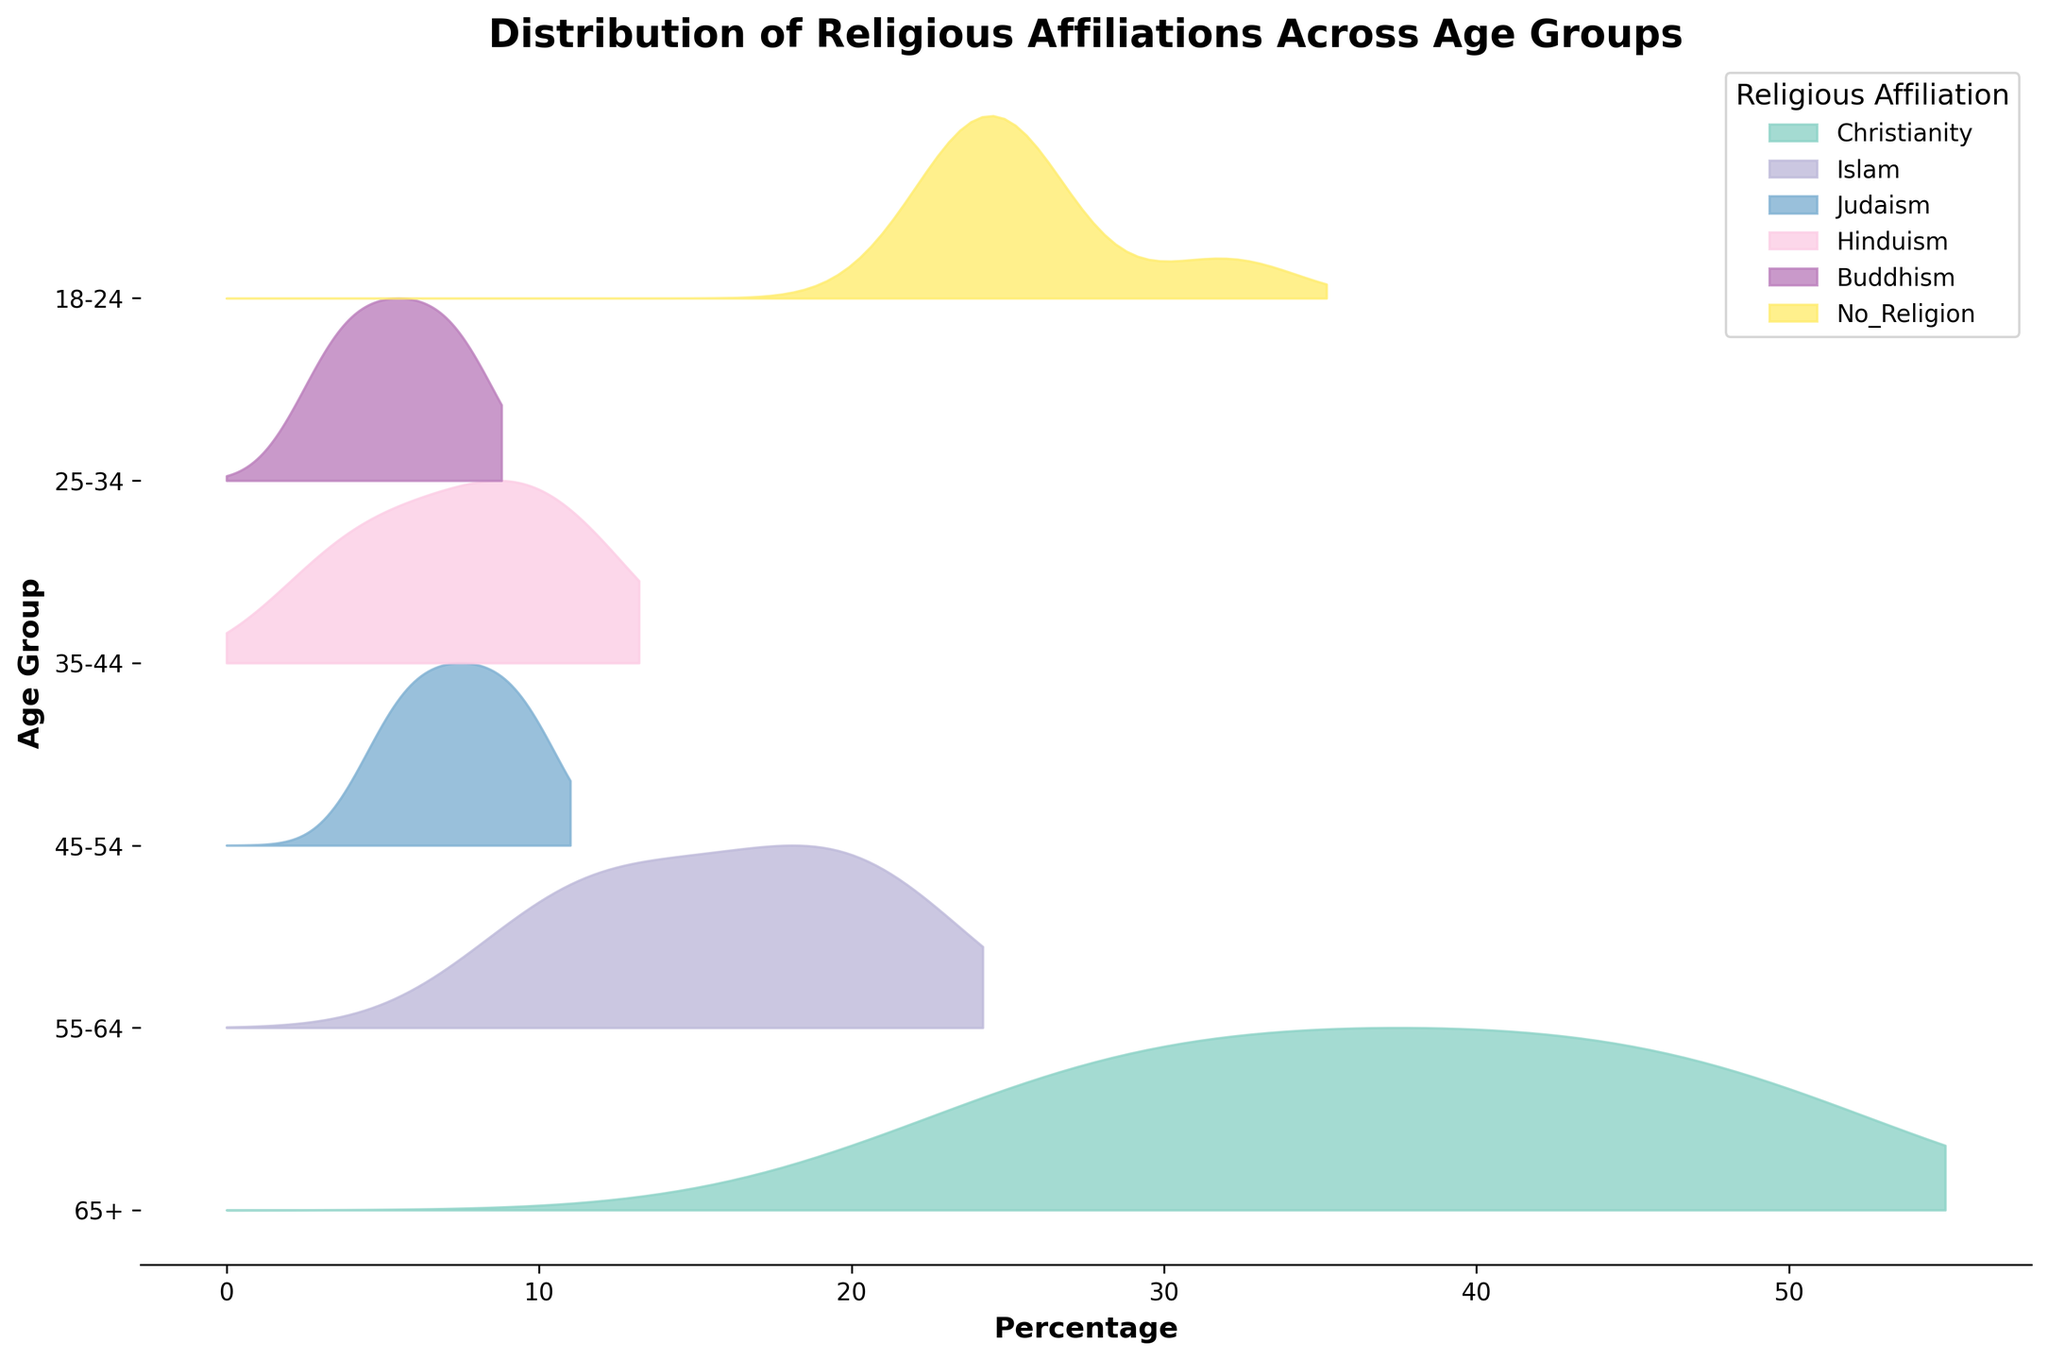What is the title of the figure? The title is usually placed at the top of the figure. In this case, looking at the title provided in the code, it is "Distribution of Religious Affiliations Across Age Groups".
Answer: Distribution of Religious Affiliations Across Age Groups How many age groups are represented in the plot? The y-axis represents the age groups. From the description and data provided, there are six age groups: 18-24, 25-34, 35-44, 45-54, 55-64, and 65+.
Answer: 6 Which religious affiliation has the highest percentage in the 65+ age group? From the provided data, look at the values for each religious affiliation in the 65+ age group. Christianity has the highest value at 50%.
Answer: Christianity Which two age groups have the identical percentages for people with no religion? Look for the "No_Religion" column in the data row-wise to find matching values. Both the 45-54 and 55-64 age groups have 25%.
Answer: 45-54 and 55-64 What's the overall trend of the Christian population across the age groups? Review the "Christianity" percentages from younger to older age groups in the data, you will see it increases steadily from 25% in 18-24 to 50% in 65+.
Answer: Increasing Compare the percentage of people practicing Islam in the 18-24 and 35-44 age groups. Which group has a higher percentage? From the data, Islam has 20% in the 18-24 age group and 18% in the 35-44 age group. Thus, the 18-24 group has a higher percentage.
Answer: 18-24 What percentage of Judaism is observed in the 55-64 age group? Look at the "Judaism" column for the 55-64 age group. It has a value of 9%.
Answer: 9% Which religious affiliation shows a decreasing trend as the age group increases? By reviewing each religious affiliation across the age groups, Buddhism shows a decreasing trend from 8% in 18-24 to 3% in 65+.
Answer: Buddhism What is the sum of people identifying as Hindu across all age groups? Take the values from the "Hinduism" column: 10 + 12 + 9 + 7 + 5 + 3. Sum them up: 10 + 12 + 9 + 7 + 5 + 3 = 46%.
Answer: 46% Which age group has the most diverse distribution of religious affiliations? By visually comparing the ridgelines' spread and height for each age group, the 18-24 age group appears more diverse, as no single religion is overwhelmingly dominant.
Answer: 18-24 